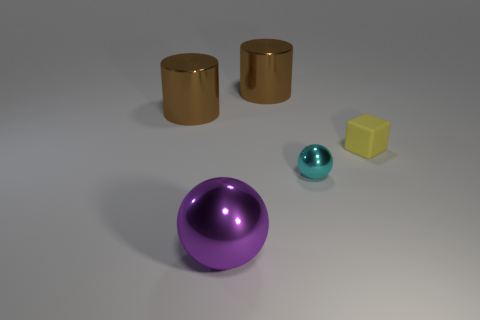Is the color of the small rubber object the same as the large shiny object that is in front of the small cyan object?
Keep it short and to the point. No. How many objects are either large yellow matte things or things that are behind the tiny metal ball?
Give a very brief answer. 3. What material is the thing that is both to the left of the tiny metal sphere and in front of the matte block?
Your answer should be compact. Metal. There is a small object in front of the yellow block; what material is it?
Keep it short and to the point. Metal. What is the color of the tiny thing that is made of the same material as the big purple thing?
Your answer should be very brief. Cyan. There is a large purple object; does it have the same shape as the tiny object in front of the tiny yellow block?
Ensure brevity in your answer.  Yes. There is a small cyan ball; are there any metal things behind it?
Provide a short and direct response. Yes. Does the rubber cube have the same size as the ball that is behind the large purple sphere?
Your answer should be very brief. Yes. Is there a purple shiny thing of the same shape as the small cyan thing?
Offer a very short reply. Yes. The metal object that is on the right side of the big purple object and behind the small sphere has what shape?
Keep it short and to the point. Cylinder. 